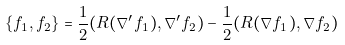Convert formula to latex. <formula><loc_0><loc_0><loc_500><loc_500>\{ f _ { 1 } , f _ { 2 } \} = \frac { 1 } { 2 } ( R ( \nabla ^ { \prime } f _ { 1 } ) , \nabla ^ { \prime } f _ { 2 } ) - \frac { 1 } { 2 } ( R ( \nabla f _ { 1 } ) , \nabla f _ { 2 } ) \</formula> 